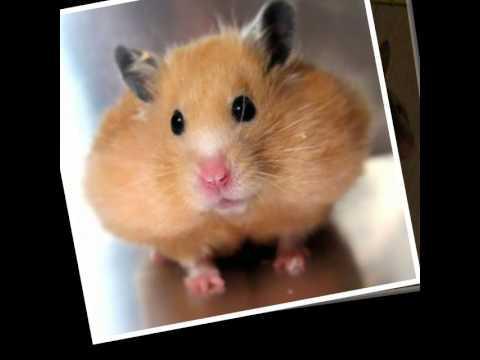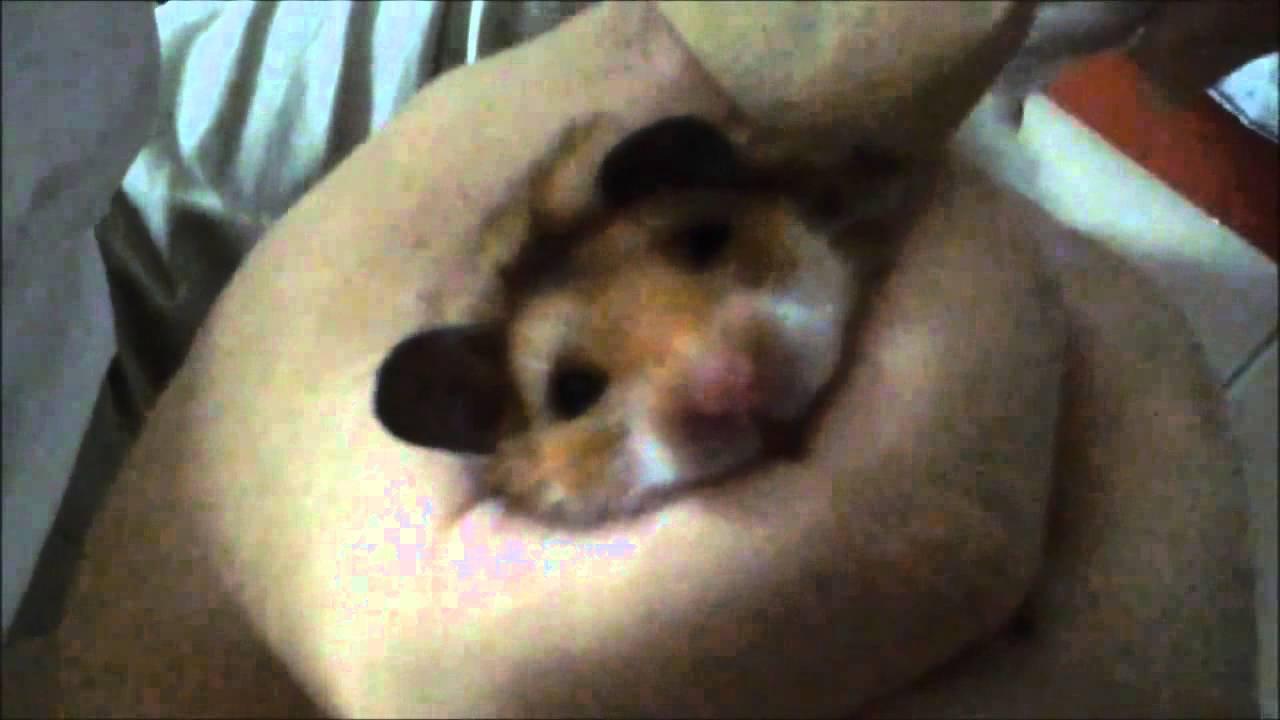The first image is the image on the left, the second image is the image on the right. Given the left and right images, does the statement "At least one of the rodents is outside." hold true? Answer yes or no. No. The first image is the image on the left, the second image is the image on the right. For the images displayed, is the sentence "The image on the left shows a single rodent standing on its back legs." factually correct? Answer yes or no. No. 